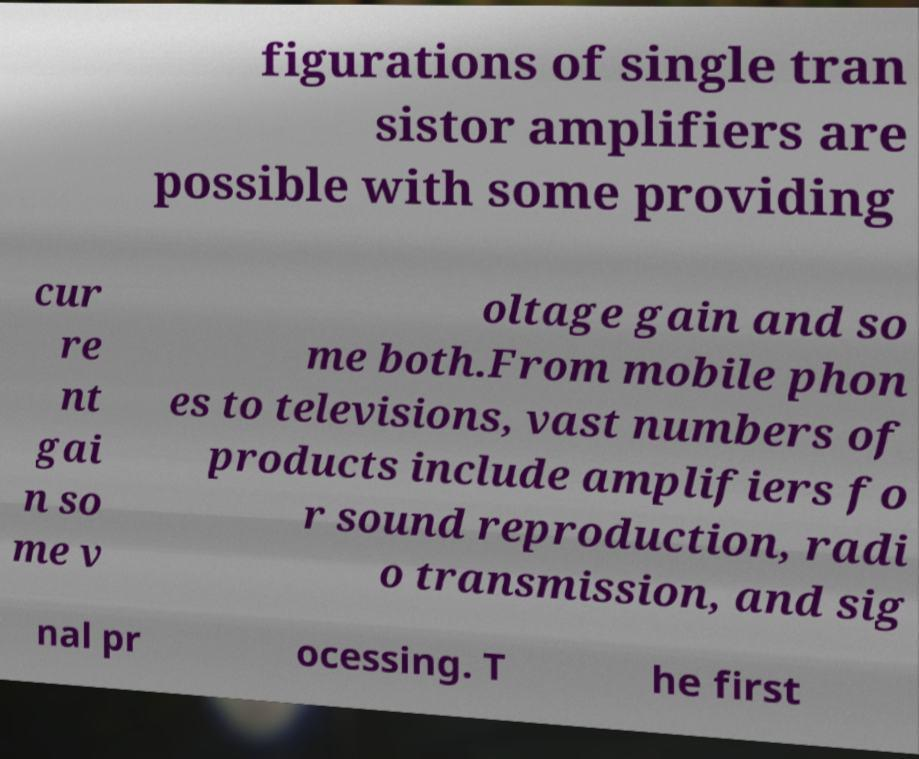Could you extract and type out the text from this image? figurations of single tran sistor amplifiers are possible with some providing cur re nt gai n so me v oltage gain and so me both.From mobile phon es to televisions, vast numbers of products include amplifiers fo r sound reproduction, radi o transmission, and sig nal pr ocessing. T he first 